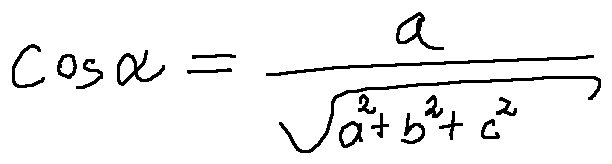<formula> <loc_0><loc_0><loc_500><loc_500>\cos \alpha = \frac { a } { \sqrt { a ^ { 2 } + b ^ { 2 } + c ^ { 2 } } }</formula> 